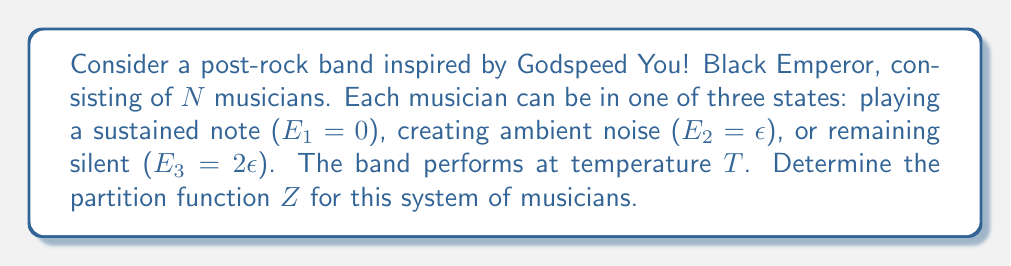Can you solve this math problem? To solve this problem, we'll follow these steps:

1) Recall the general form of the partition function:
   $$ Z = \sum_i g_i e^{-\beta E_i} $$
   where $g_i$ is the degeneracy of state $i$, $\beta = \frac{1}{k_B T}$, and $E_i$ is the energy of state $i$.

2) In this case, we have three possible states for each musician:
   - $E_1 = 0$ (sustained note)
   - $E_2 = \epsilon$ (ambient noise)
   - $E_3 = 2\epsilon$ (silence)

3) For a single musician, the partition function would be:
   $$ Z_1 = e^{-\beta \cdot 0} + e^{-\beta \epsilon} + e^{-\beta \cdot 2\epsilon} = 1 + e^{-\beta \epsilon} + e^{-2\beta \epsilon} $$

4) Since we have $N$ independent musicians, and each can be in any of these states, the total partition function is the product of the individual partition functions:
   $$ Z = (Z_1)^N = (1 + e^{-\beta \epsilon} + e^{-2\beta \epsilon})^N $$

5) This can be written more compactly as:
   $$ Z = \left(\sum_{i=0}^2 e^{-i\beta \epsilon}\right)^N $$

This final expression represents the partition function for the system of $N$ musicians in the post-rock band.
Answer: $Z = (1 + e^{-\beta \epsilon} + e^{-2\beta \epsilon})^N$ 